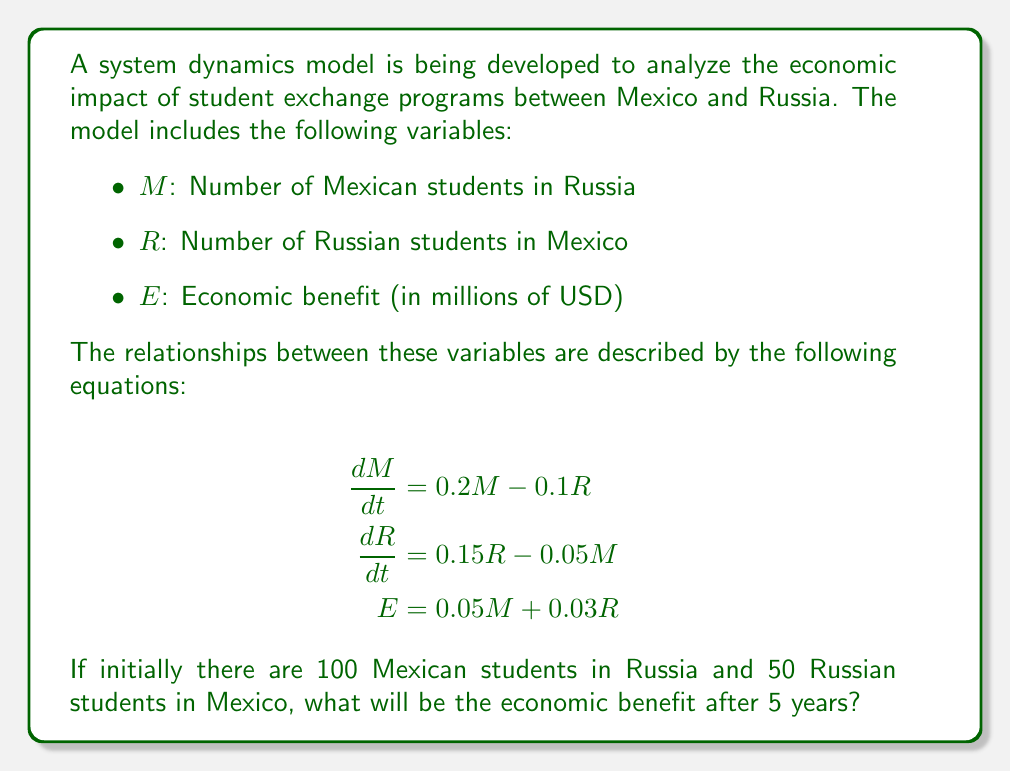Can you solve this math problem? To solve this problem, we need to follow these steps:

1. Solve the system of differential equations to find $M$ and $R$ after 5 years.
2. Use the values of $M$ and $R$ to calculate the economic benefit $E$.

Step 1: Solving the system of differential equations

The system of differential equations is:

$$\frac{dM}{dt} = 0.2M - 0.1R$$
$$\frac{dR}{dt} = 0.15R - 0.05M$$

This is a linear system of first-order differential equations. We can solve it using matrix methods or numerical integration. For simplicity, we'll use Euler's method with a small time step.

Let's use a time step of 0.1 years for 50 iterations (5 years total).

Initial conditions: $M_0 = 100$, $R_0 = 50$

For each iteration $i$:
$$M_{i+1} = M_i + (0.2M_i - 0.1R_i) \times 0.1$$
$$R_{i+1} = R_i + (0.15R_i - 0.05M_i) \times 0.1$$

After 50 iterations:
$M_{50} \approx 161.8$
$R_{50} \approx 95.4$

Step 2: Calculating the economic benefit

Using the equation for economic benefit:

$$E = 0.05M + 0.03R$$

We can now substitute the values we found:

$$E = 0.05 \times 161.8 + 0.03 \times 95.4$$
$$E = 8.09 + 2.862$$
$$E = 10.952$$

Therefore, the economic benefit after 5 years is approximately 10.952 million USD.
Answer: $10.952 million USD 